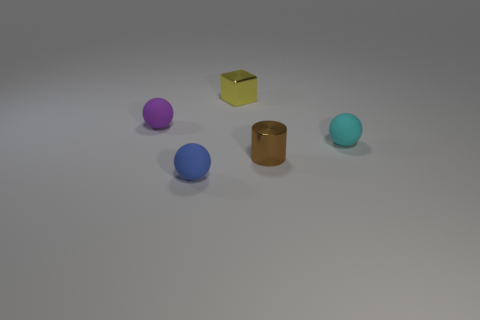Add 4 gray rubber things. How many objects exist? 9 Subtract all cylinders. How many objects are left? 4 Add 1 small yellow metal things. How many small yellow metal things are left? 2 Add 1 yellow objects. How many yellow objects exist? 2 Subtract 0 cyan cylinders. How many objects are left? 5 Subtract all rubber balls. Subtract all purple rubber spheres. How many objects are left? 1 